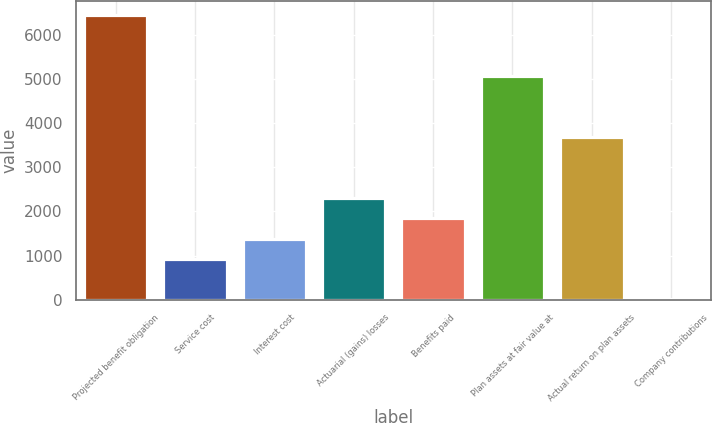Convert chart. <chart><loc_0><loc_0><loc_500><loc_500><bar_chart><fcel>Projected benefit obligation<fcel>Service cost<fcel>Interest cost<fcel>Actuarial (gains) losses<fcel>Benefits paid<fcel>Plan assets at fair value at<fcel>Actual return on plan assets<fcel>Company contributions<nl><fcel>6442.2<fcel>924.6<fcel>1384.4<fcel>2304<fcel>1844.2<fcel>5062.8<fcel>3683.4<fcel>5<nl></chart> 